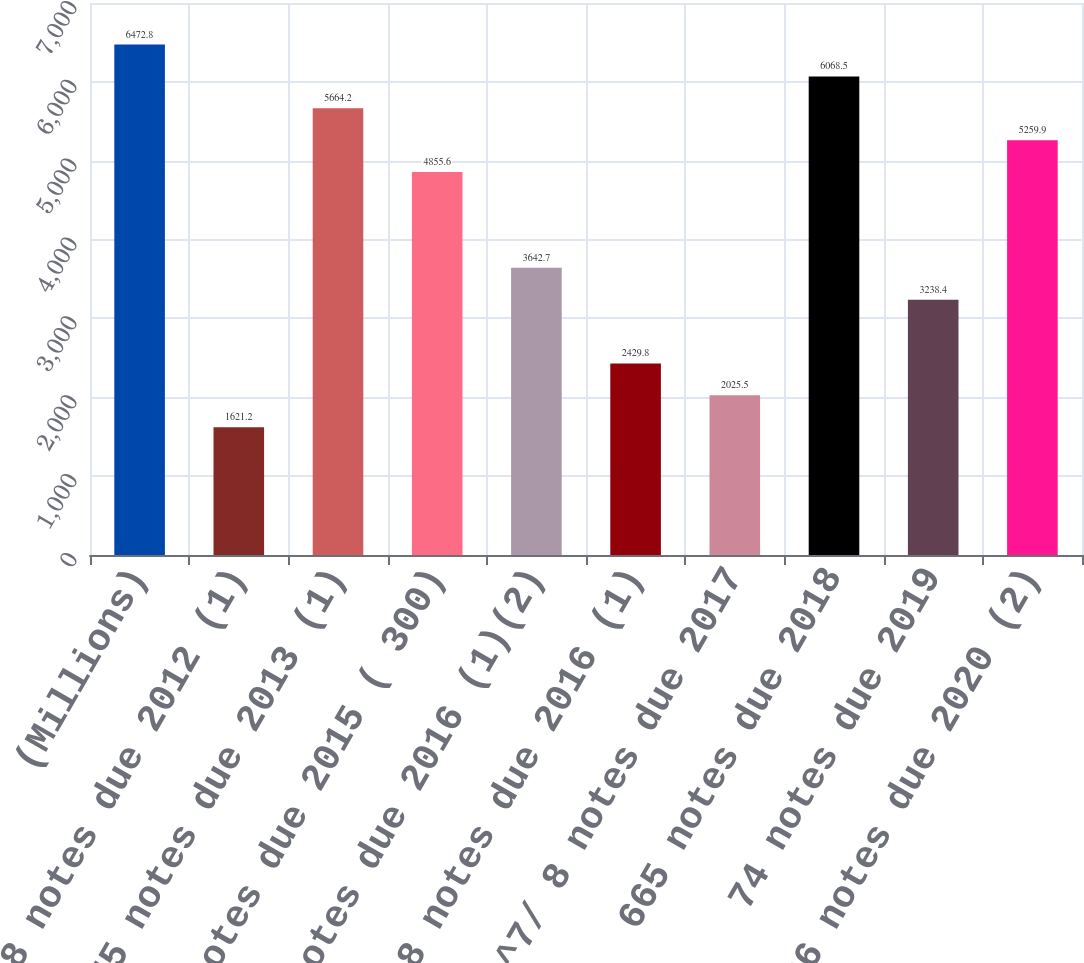<chart> <loc_0><loc_0><loc_500><loc_500><bar_chart><fcel>(Millions)<fcel>6 ^7/ 8 notes due 2012 (1)<fcel>575 notes due 2013 (1)<fcel>3 ^7/ 8 notes due 2015 ( 300)<fcel>19 notes due 2016 (1)(2)<fcel>7 ^3/ 8 notes due 2016 (1)<fcel>6 ^7/ 8 notes due 2017<fcel>665 notes due 2018<fcel>74 notes due 2019<fcel>36 notes due 2020 (2)<nl><fcel>6472.8<fcel>1621.2<fcel>5664.2<fcel>4855.6<fcel>3642.7<fcel>2429.8<fcel>2025.5<fcel>6068.5<fcel>3238.4<fcel>5259.9<nl></chart> 